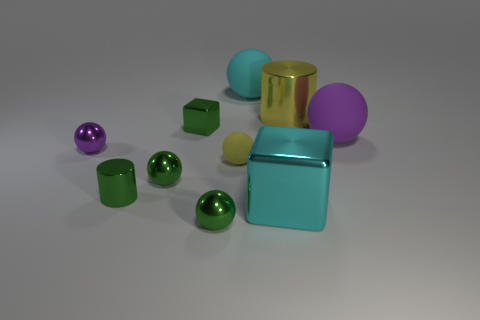Subtract 2 balls. How many balls are left? 4 Subtract all yellow balls. How many balls are left? 5 Subtract all cyan balls. How many balls are left? 5 Subtract all gray spheres. Subtract all gray cylinders. How many spheres are left? 6 Subtract all blocks. How many objects are left? 8 Subtract 1 cyan balls. How many objects are left? 9 Subtract all large green rubber balls. Subtract all metal things. How many objects are left? 3 Add 7 cyan cubes. How many cyan cubes are left? 8 Add 8 cyan rubber things. How many cyan rubber things exist? 9 